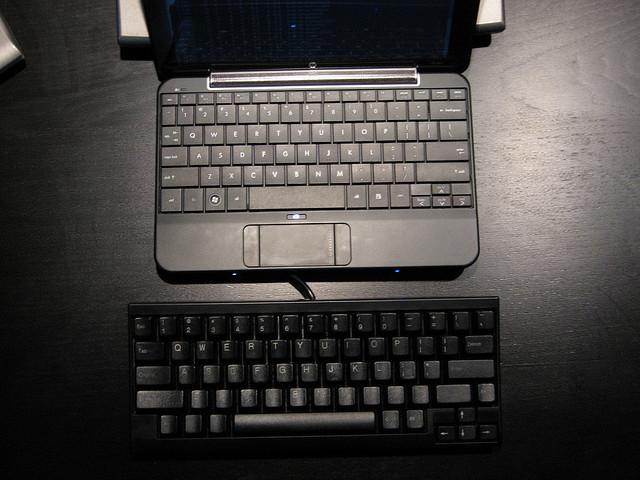How many keyboards are there?
Quick response, please. 2. What color is the keyboard?
Give a very brief answer. Black. Is there a computer mouse on the desk?
Answer briefly. No. What color is the computer?
Answer briefly. Black. Why are there two keyboards?
Be succinct. Don't know. Is that a laptop?
Short answer required. Yes. 